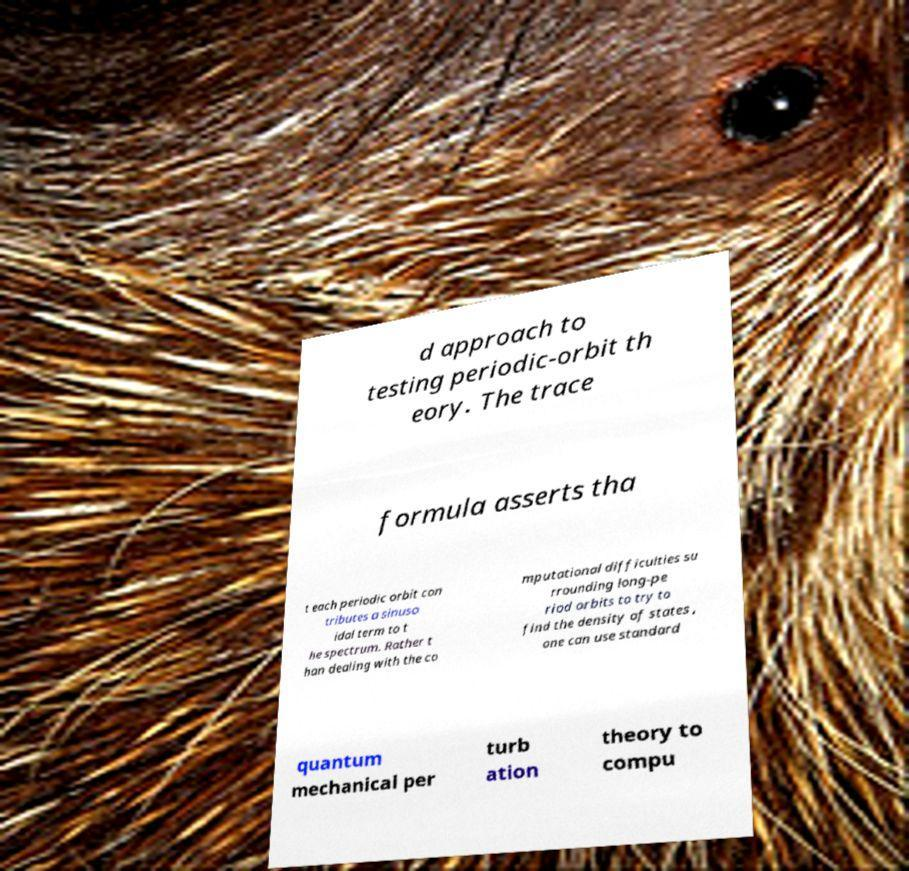There's text embedded in this image that I need extracted. Can you transcribe it verbatim? d approach to testing periodic-orbit th eory. The trace formula asserts tha t each periodic orbit con tributes a sinuso idal term to t he spectrum. Rather t han dealing with the co mputational difficulties su rrounding long-pe riod orbits to try to find the density of states , one can use standard quantum mechanical per turb ation theory to compu 